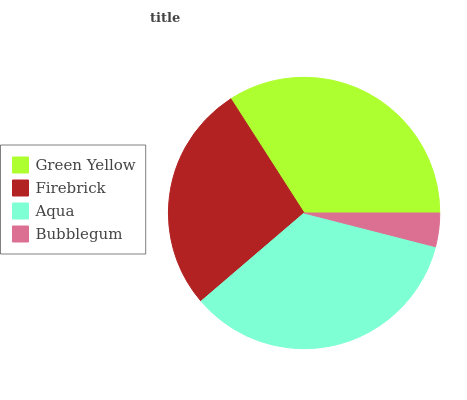Is Bubblegum the minimum?
Answer yes or no. Yes. Is Aqua the maximum?
Answer yes or no. Yes. Is Firebrick the minimum?
Answer yes or no. No. Is Firebrick the maximum?
Answer yes or no. No. Is Green Yellow greater than Firebrick?
Answer yes or no. Yes. Is Firebrick less than Green Yellow?
Answer yes or no. Yes. Is Firebrick greater than Green Yellow?
Answer yes or no. No. Is Green Yellow less than Firebrick?
Answer yes or no. No. Is Green Yellow the high median?
Answer yes or no. Yes. Is Firebrick the low median?
Answer yes or no. Yes. Is Firebrick the high median?
Answer yes or no. No. Is Bubblegum the low median?
Answer yes or no. No. 